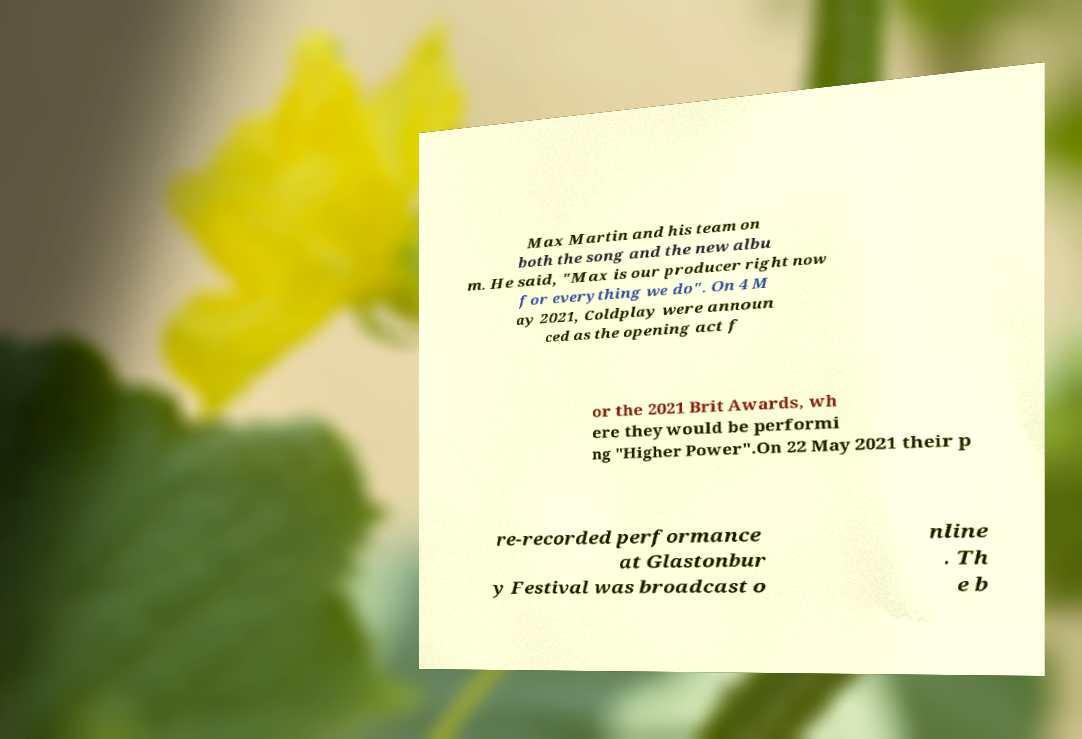There's text embedded in this image that I need extracted. Can you transcribe it verbatim? Max Martin and his team on both the song and the new albu m. He said, "Max is our producer right now for everything we do". On 4 M ay 2021, Coldplay were announ ced as the opening act f or the 2021 Brit Awards, wh ere they would be performi ng "Higher Power".On 22 May 2021 their p re-recorded performance at Glastonbur y Festival was broadcast o nline . Th e b 